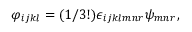Convert formula to latex. <formula><loc_0><loc_0><loc_500><loc_500>\varphi _ { i j k l } = ( 1 / 3 ! ) \epsilon _ { i j k l m n r } \psi _ { m n r } ,</formula> 